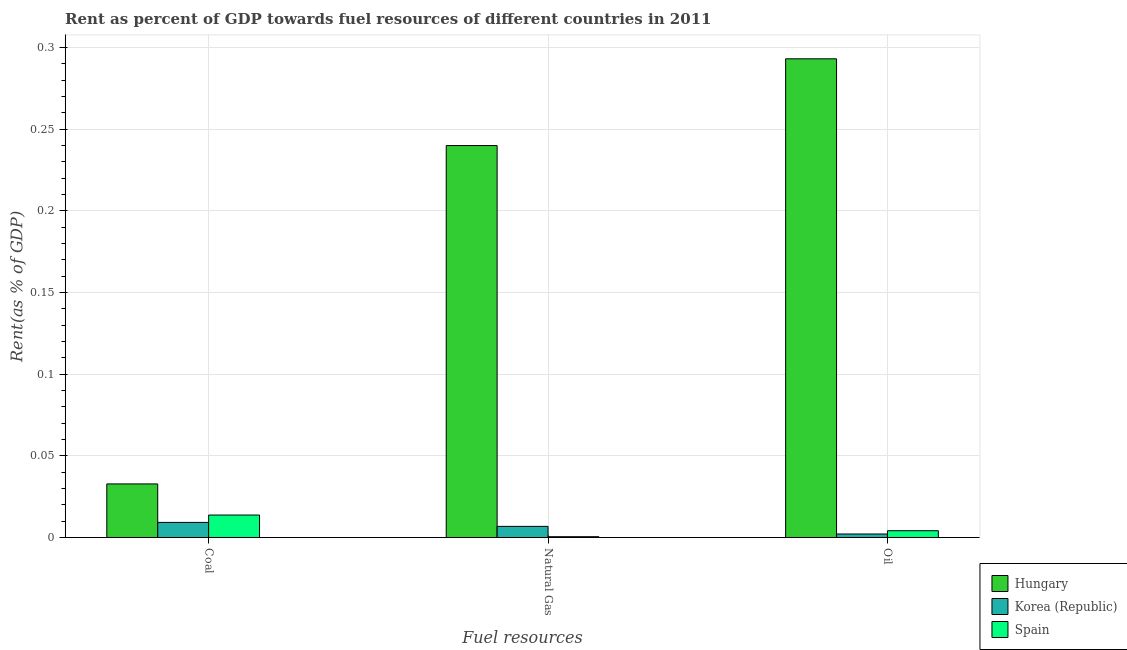How many different coloured bars are there?
Give a very brief answer. 3. Are the number of bars per tick equal to the number of legend labels?
Give a very brief answer. Yes. How many bars are there on the 1st tick from the left?
Keep it short and to the point. 3. How many bars are there on the 2nd tick from the right?
Your answer should be compact. 3. What is the label of the 3rd group of bars from the left?
Make the answer very short. Oil. What is the rent towards coal in Spain?
Provide a short and direct response. 0.01. Across all countries, what is the maximum rent towards coal?
Your answer should be very brief. 0.03. Across all countries, what is the minimum rent towards coal?
Give a very brief answer. 0.01. In which country was the rent towards oil maximum?
Provide a succinct answer. Hungary. What is the total rent towards coal in the graph?
Your answer should be very brief. 0.06. What is the difference between the rent towards natural gas in Hungary and that in Spain?
Keep it short and to the point. 0.24. What is the difference between the rent towards natural gas in Spain and the rent towards oil in Korea (Republic)?
Your answer should be compact. -0. What is the average rent towards natural gas per country?
Give a very brief answer. 0.08. What is the difference between the rent towards coal and rent towards oil in Hungary?
Provide a succinct answer. -0.26. What is the ratio of the rent towards natural gas in Hungary to that in Korea (Republic)?
Make the answer very short. 35.22. Is the rent towards oil in Hungary less than that in Spain?
Make the answer very short. No. What is the difference between the highest and the second highest rent towards natural gas?
Make the answer very short. 0.23. What is the difference between the highest and the lowest rent towards coal?
Offer a very short reply. 0.02. In how many countries, is the rent towards coal greater than the average rent towards coal taken over all countries?
Your answer should be compact. 1. What does the 2nd bar from the left in Natural Gas represents?
Make the answer very short. Korea (Republic). Are all the bars in the graph horizontal?
Offer a terse response. No. What is the difference between two consecutive major ticks on the Y-axis?
Offer a very short reply. 0.05. Does the graph contain any zero values?
Make the answer very short. No. How many legend labels are there?
Provide a succinct answer. 3. What is the title of the graph?
Your response must be concise. Rent as percent of GDP towards fuel resources of different countries in 2011. Does "East Asia (all income levels)" appear as one of the legend labels in the graph?
Keep it short and to the point. No. What is the label or title of the X-axis?
Offer a terse response. Fuel resources. What is the label or title of the Y-axis?
Keep it short and to the point. Rent(as % of GDP). What is the Rent(as % of GDP) of Hungary in Coal?
Make the answer very short. 0.03. What is the Rent(as % of GDP) in Korea (Republic) in Coal?
Provide a short and direct response. 0.01. What is the Rent(as % of GDP) in Spain in Coal?
Give a very brief answer. 0.01. What is the Rent(as % of GDP) of Hungary in Natural Gas?
Make the answer very short. 0.24. What is the Rent(as % of GDP) in Korea (Republic) in Natural Gas?
Keep it short and to the point. 0.01. What is the Rent(as % of GDP) in Spain in Natural Gas?
Your answer should be compact. 0. What is the Rent(as % of GDP) of Hungary in Oil?
Offer a very short reply. 0.29. What is the Rent(as % of GDP) of Korea (Republic) in Oil?
Your answer should be very brief. 0. What is the Rent(as % of GDP) in Spain in Oil?
Provide a short and direct response. 0. Across all Fuel resources, what is the maximum Rent(as % of GDP) of Hungary?
Keep it short and to the point. 0.29. Across all Fuel resources, what is the maximum Rent(as % of GDP) of Korea (Republic)?
Give a very brief answer. 0.01. Across all Fuel resources, what is the maximum Rent(as % of GDP) in Spain?
Keep it short and to the point. 0.01. Across all Fuel resources, what is the minimum Rent(as % of GDP) in Hungary?
Your response must be concise. 0.03. Across all Fuel resources, what is the minimum Rent(as % of GDP) in Korea (Republic)?
Your answer should be very brief. 0. Across all Fuel resources, what is the minimum Rent(as % of GDP) of Spain?
Keep it short and to the point. 0. What is the total Rent(as % of GDP) in Hungary in the graph?
Keep it short and to the point. 0.57. What is the total Rent(as % of GDP) in Korea (Republic) in the graph?
Your response must be concise. 0.02. What is the total Rent(as % of GDP) in Spain in the graph?
Offer a terse response. 0.02. What is the difference between the Rent(as % of GDP) of Hungary in Coal and that in Natural Gas?
Ensure brevity in your answer.  -0.21. What is the difference between the Rent(as % of GDP) in Korea (Republic) in Coal and that in Natural Gas?
Keep it short and to the point. 0. What is the difference between the Rent(as % of GDP) in Spain in Coal and that in Natural Gas?
Keep it short and to the point. 0.01. What is the difference between the Rent(as % of GDP) in Hungary in Coal and that in Oil?
Provide a short and direct response. -0.26. What is the difference between the Rent(as % of GDP) of Korea (Republic) in Coal and that in Oil?
Give a very brief answer. 0.01. What is the difference between the Rent(as % of GDP) of Spain in Coal and that in Oil?
Your response must be concise. 0.01. What is the difference between the Rent(as % of GDP) of Hungary in Natural Gas and that in Oil?
Offer a very short reply. -0.05. What is the difference between the Rent(as % of GDP) in Korea (Republic) in Natural Gas and that in Oil?
Your answer should be very brief. 0. What is the difference between the Rent(as % of GDP) of Spain in Natural Gas and that in Oil?
Your answer should be very brief. -0. What is the difference between the Rent(as % of GDP) of Hungary in Coal and the Rent(as % of GDP) of Korea (Republic) in Natural Gas?
Provide a short and direct response. 0.03. What is the difference between the Rent(as % of GDP) in Hungary in Coal and the Rent(as % of GDP) in Spain in Natural Gas?
Offer a very short reply. 0.03. What is the difference between the Rent(as % of GDP) of Korea (Republic) in Coal and the Rent(as % of GDP) of Spain in Natural Gas?
Your answer should be compact. 0.01. What is the difference between the Rent(as % of GDP) of Hungary in Coal and the Rent(as % of GDP) of Korea (Republic) in Oil?
Ensure brevity in your answer.  0.03. What is the difference between the Rent(as % of GDP) of Hungary in Coal and the Rent(as % of GDP) of Spain in Oil?
Offer a terse response. 0.03. What is the difference between the Rent(as % of GDP) in Korea (Republic) in Coal and the Rent(as % of GDP) in Spain in Oil?
Your answer should be compact. 0.01. What is the difference between the Rent(as % of GDP) of Hungary in Natural Gas and the Rent(as % of GDP) of Korea (Republic) in Oil?
Make the answer very short. 0.24. What is the difference between the Rent(as % of GDP) of Hungary in Natural Gas and the Rent(as % of GDP) of Spain in Oil?
Provide a succinct answer. 0.24. What is the difference between the Rent(as % of GDP) of Korea (Republic) in Natural Gas and the Rent(as % of GDP) of Spain in Oil?
Offer a very short reply. 0. What is the average Rent(as % of GDP) in Hungary per Fuel resources?
Provide a succinct answer. 0.19. What is the average Rent(as % of GDP) in Korea (Republic) per Fuel resources?
Your response must be concise. 0.01. What is the average Rent(as % of GDP) in Spain per Fuel resources?
Offer a very short reply. 0.01. What is the difference between the Rent(as % of GDP) in Hungary and Rent(as % of GDP) in Korea (Republic) in Coal?
Your response must be concise. 0.02. What is the difference between the Rent(as % of GDP) of Hungary and Rent(as % of GDP) of Spain in Coal?
Keep it short and to the point. 0.02. What is the difference between the Rent(as % of GDP) of Korea (Republic) and Rent(as % of GDP) of Spain in Coal?
Your response must be concise. -0. What is the difference between the Rent(as % of GDP) of Hungary and Rent(as % of GDP) of Korea (Republic) in Natural Gas?
Keep it short and to the point. 0.23. What is the difference between the Rent(as % of GDP) in Hungary and Rent(as % of GDP) in Spain in Natural Gas?
Provide a short and direct response. 0.24. What is the difference between the Rent(as % of GDP) of Korea (Republic) and Rent(as % of GDP) of Spain in Natural Gas?
Offer a very short reply. 0.01. What is the difference between the Rent(as % of GDP) in Hungary and Rent(as % of GDP) in Korea (Republic) in Oil?
Your answer should be compact. 0.29. What is the difference between the Rent(as % of GDP) of Hungary and Rent(as % of GDP) of Spain in Oil?
Offer a terse response. 0.29. What is the difference between the Rent(as % of GDP) in Korea (Republic) and Rent(as % of GDP) in Spain in Oil?
Make the answer very short. -0. What is the ratio of the Rent(as % of GDP) in Hungary in Coal to that in Natural Gas?
Your answer should be very brief. 0.14. What is the ratio of the Rent(as % of GDP) of Korea (Republic) in Coal to that in Natural Gas?
Offer a very short reply. 1.35. What is the ratio of the Rent(as % of GDP) of Spain in Coal to that in Natural Gas?
Make the answer very short. 28.57. What is the ratio of the Rent(as % of GDP) of Hungary in Coal to that in Oil?
Provide a succinct answer. 0.11. What is the ratio of the Rent(as % of GDP) in Korea (Republic) in Coal to that in Oil?
Your answer should be very brief. 4.31. What is the ratio of the Rent(as % of GDP) of Spain in Coal to that in Oil?
Your answer should be compact. 3.31. What is the ratio of the Rent(as % of GDP) in Hungary in Natural Gas to that in Oil?
Your response must be concise. 0.82. What is the ratio of the Rent(as % of GDP) of Korea (Republic) in Natural Gas to that in Oil?
Give a very brief answer. 3.19. What is the ratio of the Rent(as % of GDP) in Spain in Natural Gas to that in Oil?
Give a very brief answer. 0.12. What is the difference between the highest and the second highest Rent(as % of GDP) in Hungary?
Provide a succinct answer. 0.05. What is the difference between the highest and the second highest Rent(as % of GDP) in Korea (Republic)?
Provide a short and direct response. 0. What is the difference between the highest and the second highest Rent(as % of GDP) in Spain?
Make the answer very short. 0.01. What is the difference between the highest and the lowest Rent(as % of GDP) in Hungary?
Offer a terse response. 0.26. What is the difference between the highest and the lowest Rent(as % of GDP) in Korea (Republic)?
Ensure brevity in your answer.  0.01. What is the difference between the highest and the lowest Rent(as % of GDP) of Spain?
Offer a terse response. 0.01. 